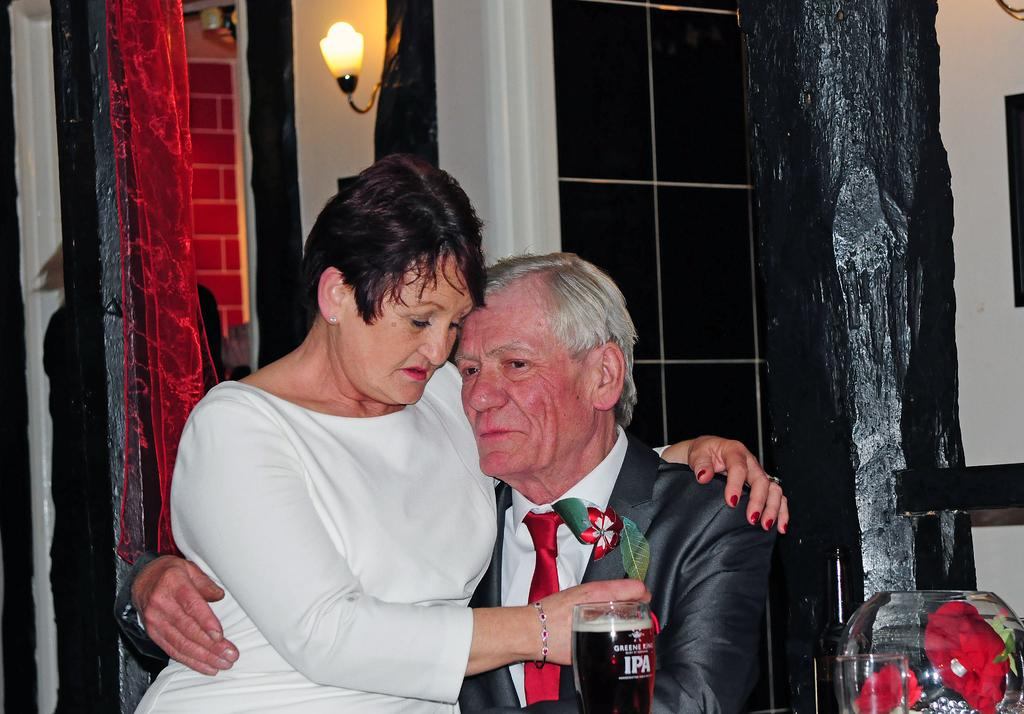How many people are present in the image? There are two people in the image, a man and a woman. What are the man and woman doing in the image? Both the man and woman are sitting on chairs. What can be seen in the background of the image? In the background of the image, there is a curtain, windows, an electric light, walls, pillars, glass tumblers, and an aquarium. Can you see any oil dripping from the aquarium in the image? There is no oil present in the image, nor is there any indication of oil dripping from the aquarium. 